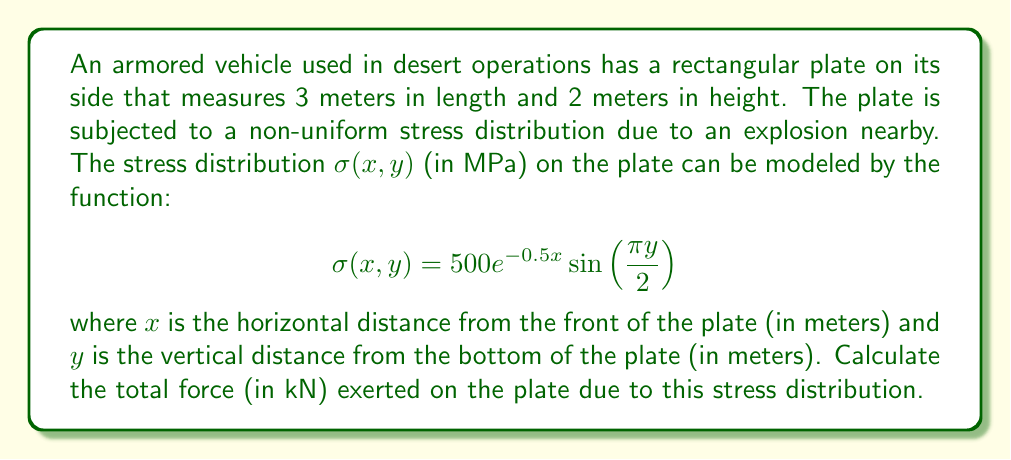Can you solve this math problem? To solve this problem, we need to integrate the stress distribution over the entire surface of the plate. The force is the integral of stress over area. Let's approach this step-by-step:

1) The total force $F$ is given by the double integral of the stress function over the area:

   $$F = \int_0^3 \int_0^2 \sigma(x,y) \, dy \, dx$$

2) Substituting the given stress function:

   $$F = \int_0^3 \int_0^2 500e^{-0.5x} \sin(\frac{\pi y}{2}) \, dy \, dx$$

3) Let's solve the inner integral with respect to $y$ first:

   $$\int_0^2 \sin(\frac{\pi y}{2}) \, dy = [-\frac{2}{\pi} \cos(\frac{\pi y}{2})]_0^2 = -\frac{2}{\pi} [\cos(\pi) - \cos(0)] = \frac{4}{\pi}$$

4) Now our integral becomes:

   $$F = \frac{2000}{\pi} \int_0^3 e^{-0.5x} \, dx$$

5) Solving this integral:

   $$F = \frac{2000}{\pi} [-2e^{-0.5x}]_0^3 = \frac{2000}{\pi} [(-2e^{-1.5}) - (-2)] = \frac{4000}{\pi} (1 - e^{-1.5})$$

6) Evaluating this expression:

   $$F \approx 1617.97 \text{ kN}$$

Therefore, the total force exerted on the plate is approximately 1618 kN.
Answer: 1618 kN 